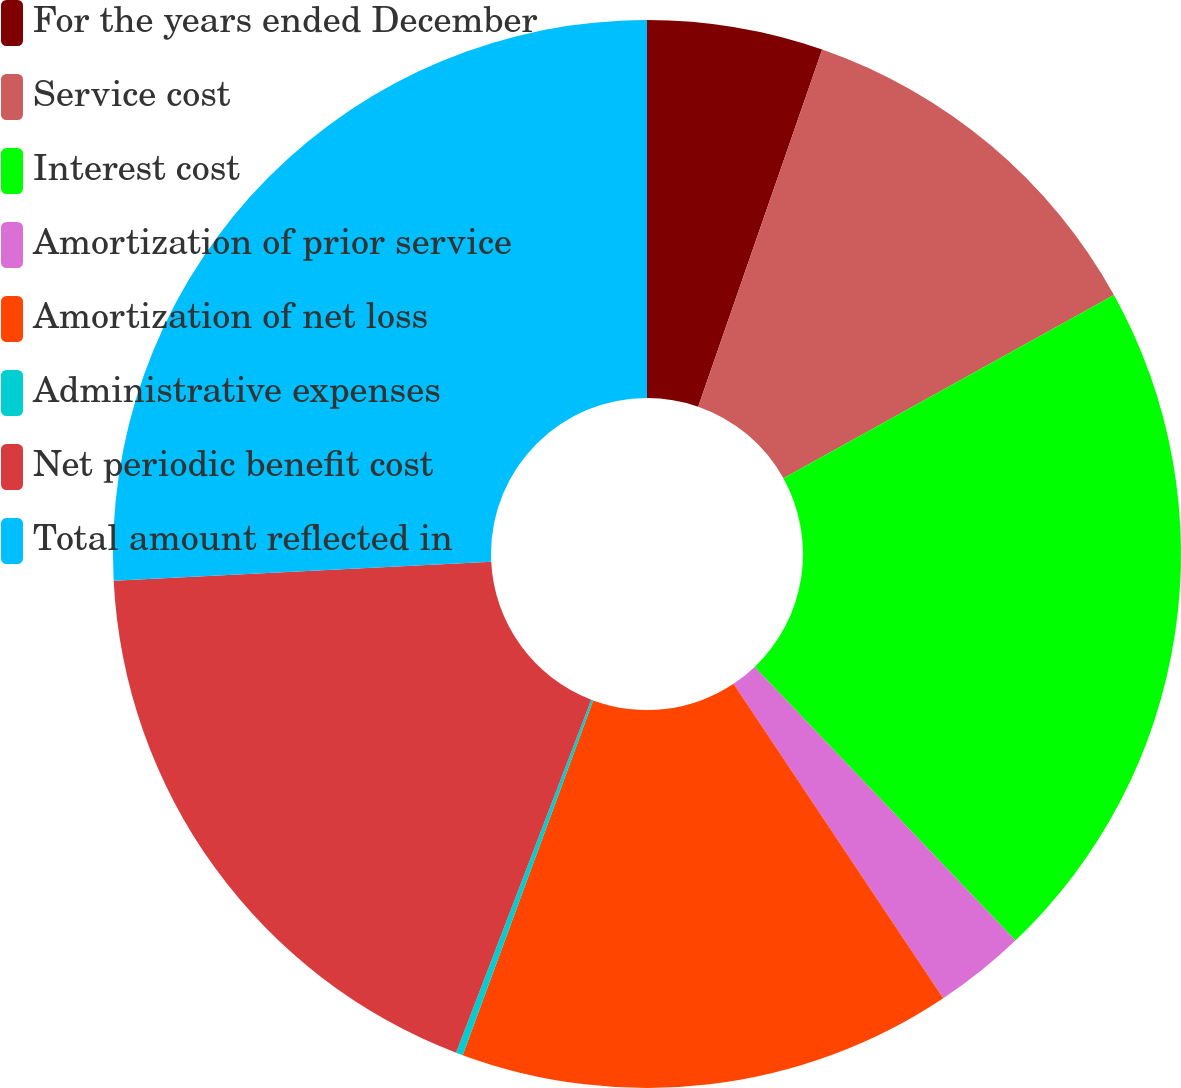Convert chart to OTSL. <chart><loc_0><loc_0><loc_500><loc_500><pie_chart><fcel>For the years ended December<fcel>Service cost<fcel>Interest cost<fcel>Amortization of prior service<fcel>Amortization of net loss<fcel>Administrative expenses<fcel>Net periodic benefit cost<fcel>Total amount reflected in<nl><fcel>5.32%<fcel>11.62%<fcel>20.94%<fcel>2.76%<fcel>14.97%<fcel>0.21%<fcel>18.38%<fcel>25.8%<nl></chart> 